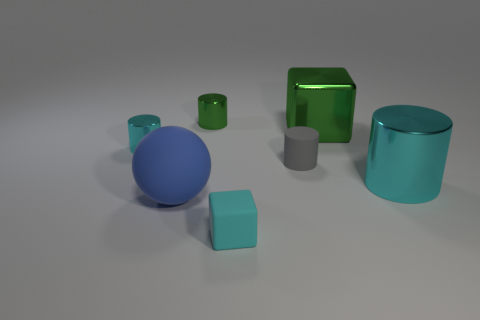Subtract all green balls. How many cyan cylinders are left? 2 Add 2 small green things. How many objects exist? 9 Subtract all green cylinders. How many cylinders are left? 3 Subtract 1 cylinders. How many cylinders are left? 3 Subtract all gray cylinders. How many cylinders are left? 3 Subtract all cylinders. How many objects are left? 3 Subtract all tiny cyan blocks. Subtract all big green things. How many objects are left? 5 Add 2 cylinders. How many cylinders are left? 6 Add 7 big yellow rubber objects. How many big yellow rubber objects exist? 7 Subtract 0 red spheres. How many objects are left? 7 